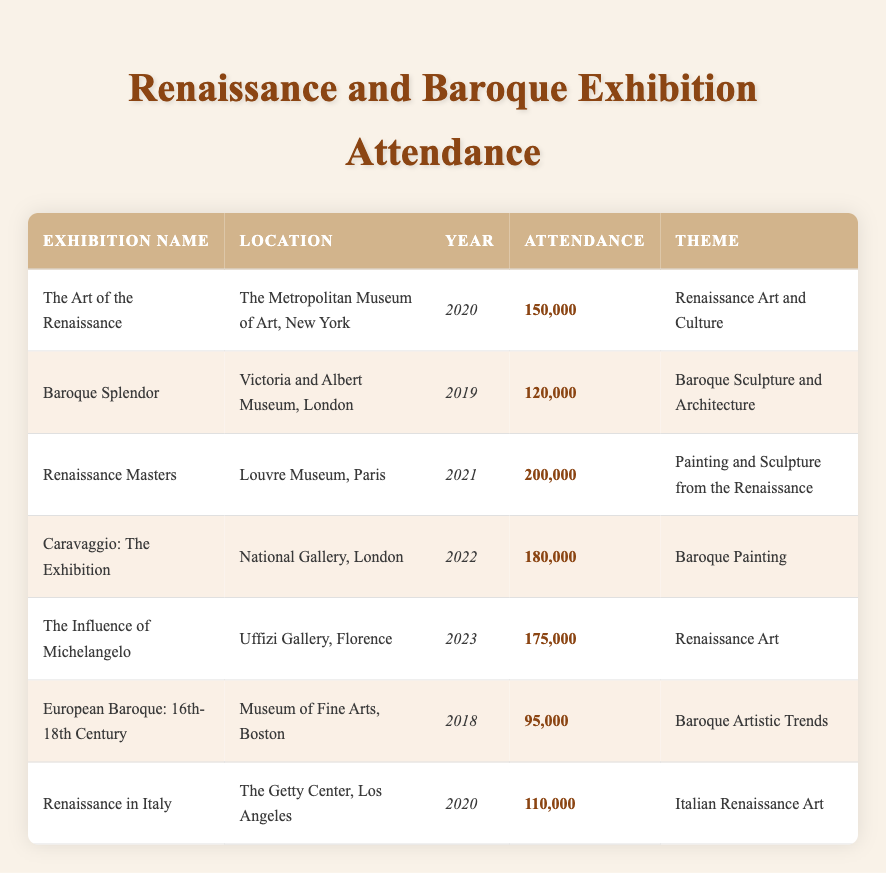What was the attendance at the "Renaissance Masters" exhibition? The table shows that the attendance for the "Renaissance Masters" exhibition at the Louvre Museum in 2021 was 200,000.
Answer: 200,000 Which exhibition had the highest attendance? By reviewing the attendance figures listed, "Renaissance Masters" with 200,000 attendees has the highest attendance.
Answer: "Renaissance Masters" How many exhibitions were held in 2020? There are two exhibitions listed for the year 2020: "The Art of the Renaissance" and "Renaissance in Italy." Thus, the total is 2 exhibitions.
Answer: 2 Is there an exhibition about Baroque sculpture and architecture? Yes, the "Baroque Splendor" exhibition specifically focuses on Baroque sculpture and architecture, as stated in the theme.
Answer: Yes What was the total attendance for all exhibitions in 2019 and 2020? The attendance in 2019 was 120,000 for "Baroque Splendor" and in 2020 was 150,000 for "The Art of the Renaissance" and 110,000 for "Renaissance in Italy." The total attendance is 120,000 + 150,000 + 110,000 = 380,000.
Answer: 380,000 Which location had an exhibition with attendance greater than 160,000? The data reveals that both the National Gallery in London (Caravaggio: The Exhibition) with 180,000 and the Uffizi Gallery in Florence (The Influence of Michelangelo) with 175,000 had attendance figures greater than 160,000.
Answer: National Gallery, Uffizi Gallery What is the average attendance of exhibitions held in the year 2022? The only exhibition in 2022 is "Caravaggio: The Exhibition," which had an attendance of 180,000. As there's only one data point, the average is simply that value, which is 180,000.
Answer: 180,000 Was the "European Baroque: 16th-18th Century" exhibition the least attended? Yes, "European Baroque: 16th-18th Century" had an attendance of 95,000, which is the lowest attendance among all the exhibitions listed.
Answer: Yes Which exhibition showcased Baroque painting? According to the table, the "Caravaggio: The Exhibition" specifically highlighted Baroque painting as its theme.
Answer: "Caravaggio: The Exhibition" 